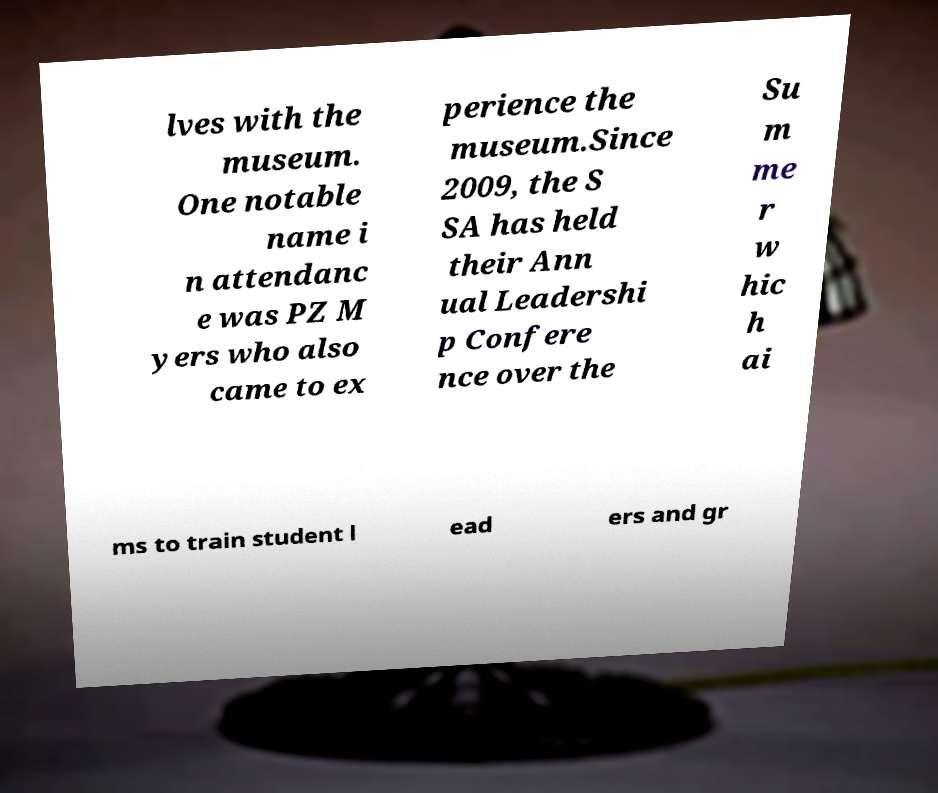There's text embedded in this image that I need extracted. Can you transcribe it verbatim? lves with the museum. One notable name i n attendanc e was PZ M yers who also came to ex perience the museum.Since 2009, the S SA has held their Ann ual Leadershi p Confere nce over the Su m me r w hic h ai ms to train student l ead ers and gr 